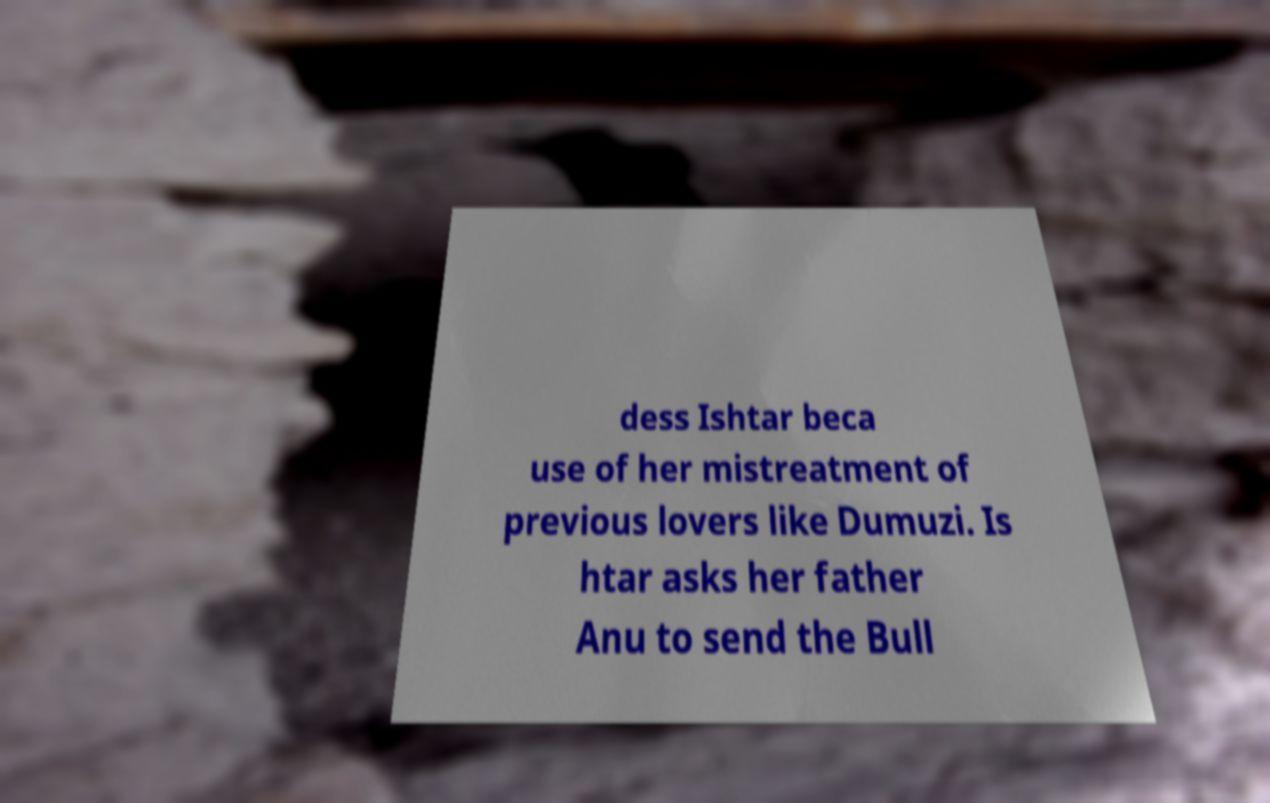Please read and relay the text visible in this image. What does it say? dess Ishtar beca use of her mistreatment of previous lovers like Dumuzi. Is htar asks her father Anu to send the Bull 